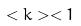<formula> <loc_0><loc_0><loc_500><loc_500>< k > < 1</formula> 